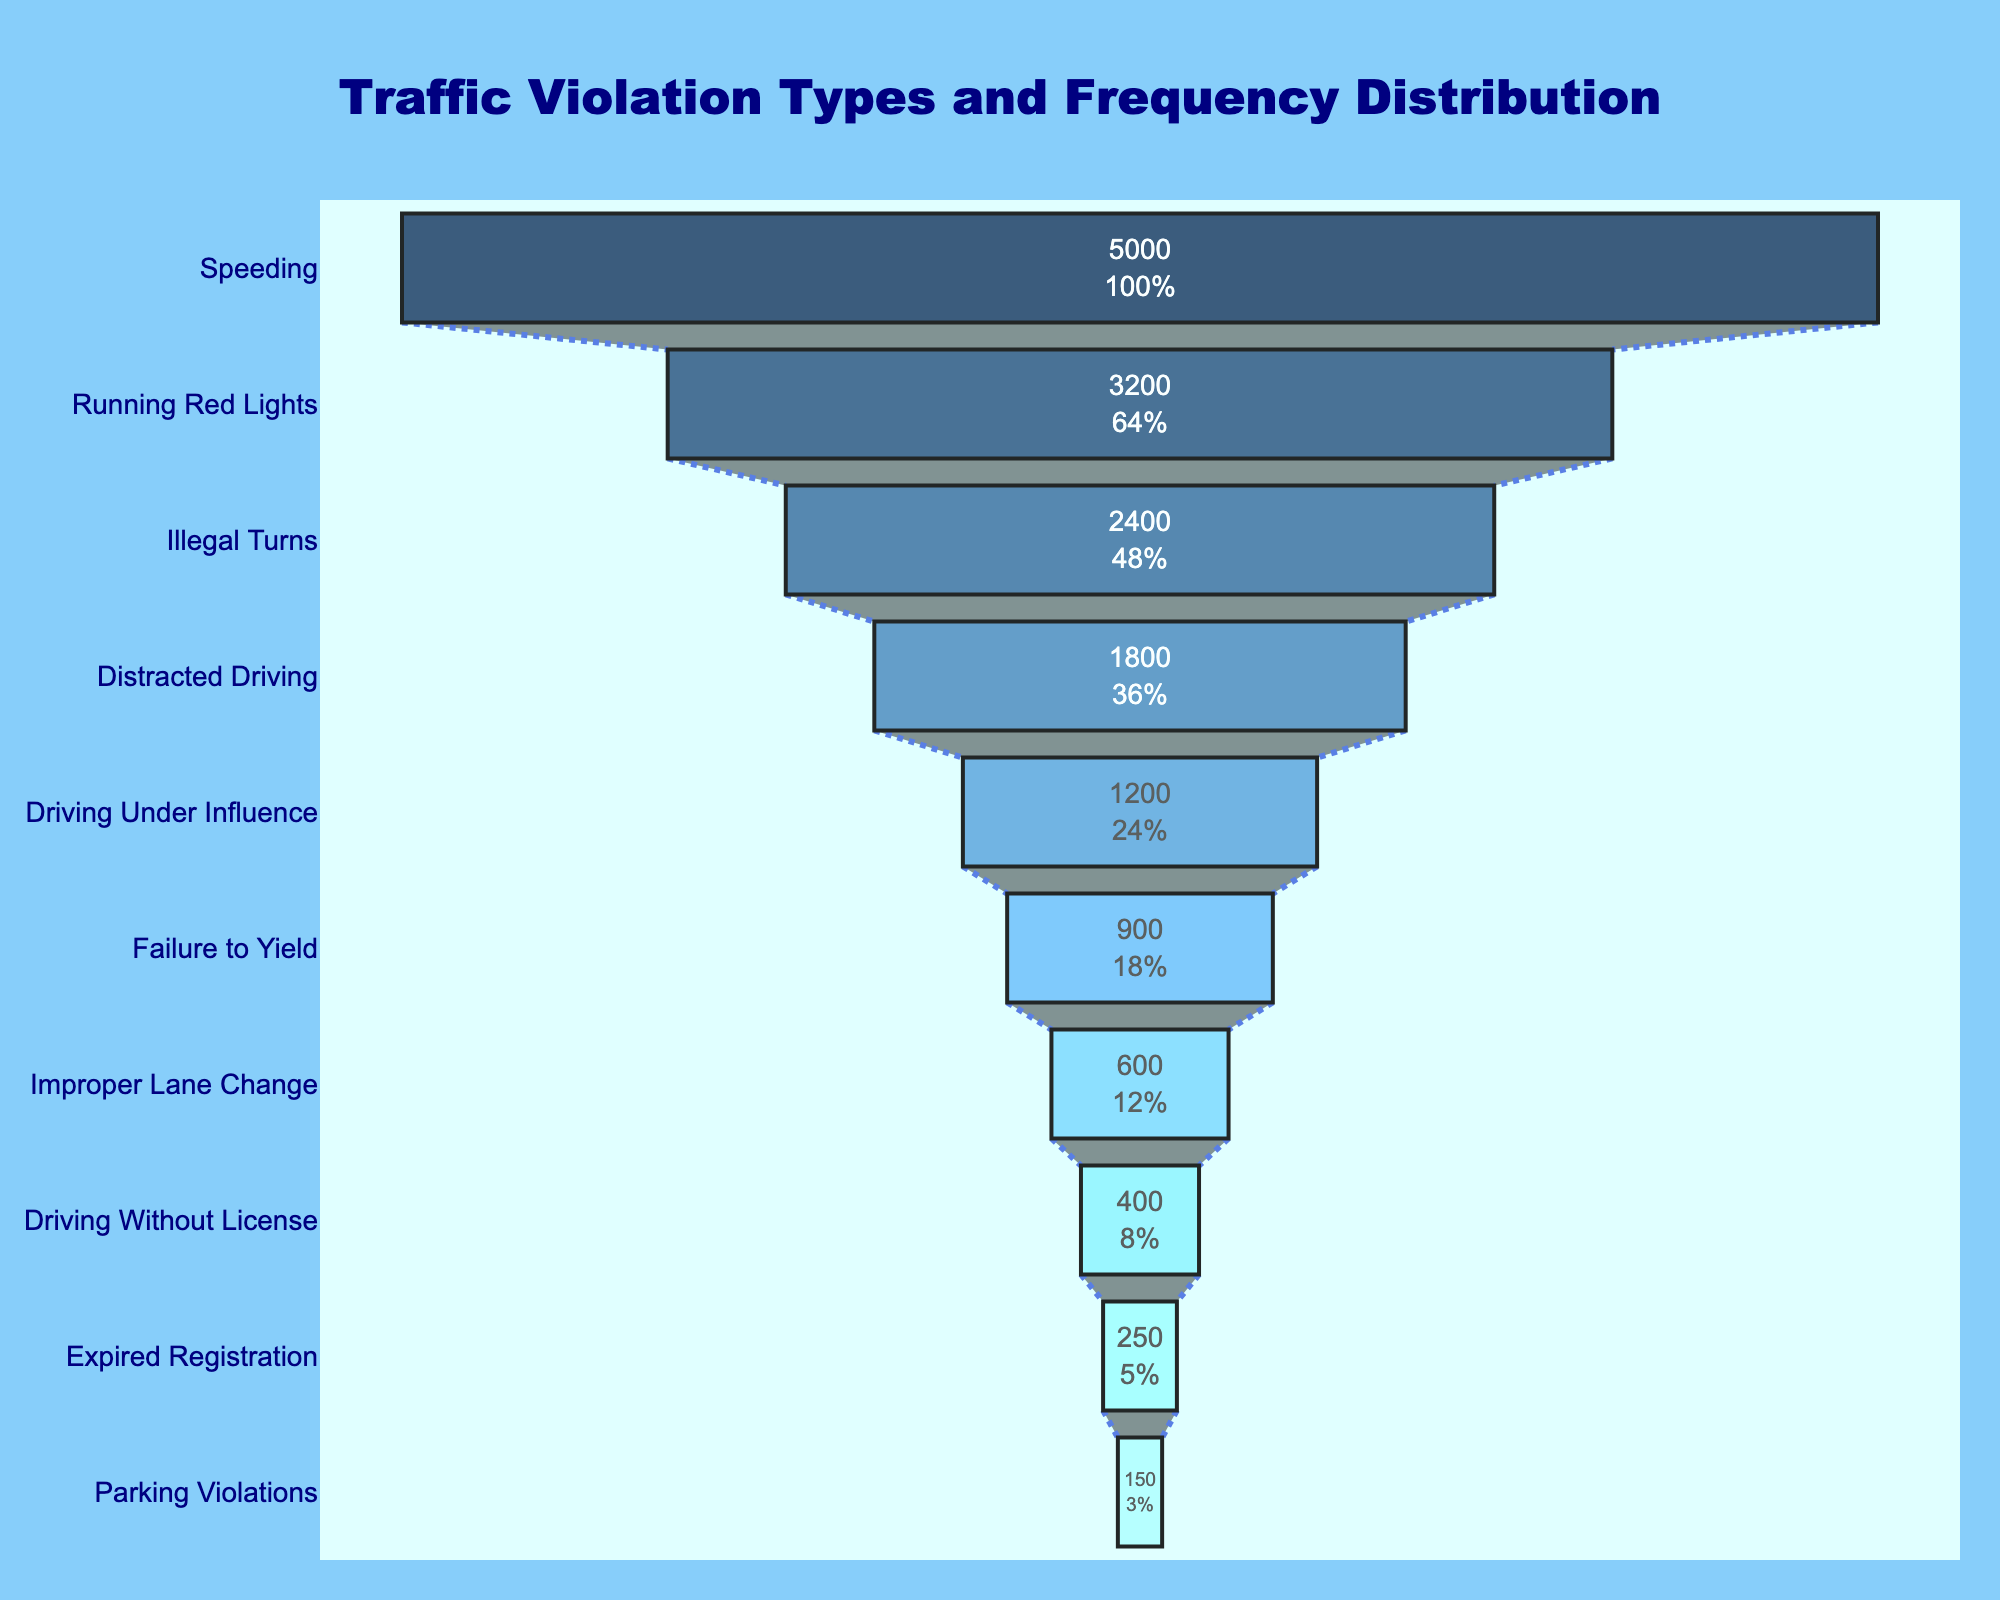What is the title of the figure? The title is located at the top of the figure. It reads "Traffic Violation Types and Frequency Distribution".
Answer: Traffic Violation Types and Frequency Distribution Which category has the highest number of violations? The topmost category in the funnel chart with the largest value is "Speeding".
Answer: Speeding What percentage of the initial value does "Running Red Lights" have? The text inside the corresponding section shows both the number and percentage value. "Running Red Lights" shows its percentage next to the value 3200.
Answer: 64% How many violations fall under the categories "Driving Without License" and "Expired Registration" combined? Add the number of violations for "Driving Without License" (400) and "Expired Registration" (250). The total is 400 + 250 = 650.
Answer: 650 Which category recorded fewer violations: "Illegal Turns" or "Driving Under Influence"? Compare the number of violations for "Illegal Turns" (2400) and "Driving Under Influence" (1200). "Driving Under Influence" has fewer violations.
Answer: Driving Under Influence What is the color of the "Distracted Driving" section? The section representing "Distracted Driving" in the funnel chart is in light blue (#6EC1FC).
Answer: Light blue What is the difference in the number of violations between "Failure to Yield" and "Improper Lane Change"? Subtract the number of violations for "Improper Lane Change" (600) from "Failure to Yield" (900). The difference is 900 - 600 = 300.
Answer: 300 What is the average number of violations for the three categories with the lowest numbers? Add the number of violations for the three lowest categories: "Parking Violations" (150), "Expired Registration" (250), "Driving Without License" (400). The total is 150 + 250 + 400 = 800. Divide by 3 to get the average: 800 / 3 ≈ 266.7.
Answer: 266.7 How does the number of "Illegal Turns" violations compare to "Running Red Lights"? "Running Red Lights" has 3200 violations, and "Illegal Turns" has 2400. Since 3200 > 2400, "Running Red Lights" has more violations.
Answer: Running Red Lights has more Which categories contribute to over half of the total violations in the chart? Calculate the total number of violations, then determine which categories together exceed half of this total. Total is 5000 + 3200 + 2400 + 1800 + 1200 + 900 + 600 + 400 + 250 + 150 = 15900. Half of 15900 is 7950. Adding the highest values starting from the top: 5000 (Speeding) + 3200 (Running Red Lights) = 8200, which is over 7950. Thus, "Speeding" and "Running Red Lights" together contribute to over half the total violations.
Answer: Speeding, Running Red Lights 